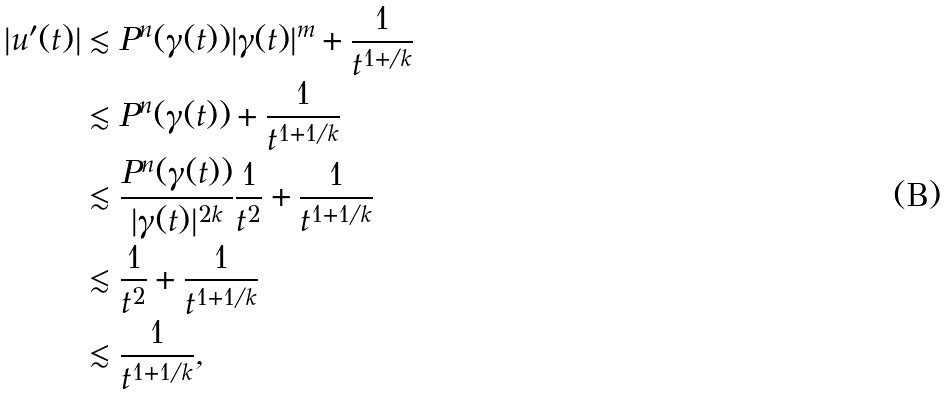Convert formula to latex. <formula><loc_0><loc_0><loc_500><loc_500>| u ^ { \prime } ( t ) | & \lesssim P ^ { n } ( \gamma ( t ) ) | \gamma ( t ) | ^ { m } + \frac { 1 } { t ^ { 1 + / k } } \\ & \lesssim P ^ { n } ( \gamma ( t ) ) + \frac { 1 } { t ^ { 1 + 1 / k } } \\ & \lesssim \frac { P ^ { n } ( \gamma ( t ) ) } { | \gamma ( t ) | ^ { 2 k } } \frac { 1 } { t ^ { 2 } } + \frac { 1 } { t ^ { 1 + 1 / k } } \\ & \lesssim \frac { 1 } { t ^ { 2 } } + \frac { 1 } { t ^ { 1 + 1 / k } } \\ & \lesssim \frac { 1 } { t ^ { 1 + 1 / k } } ,</formula> 